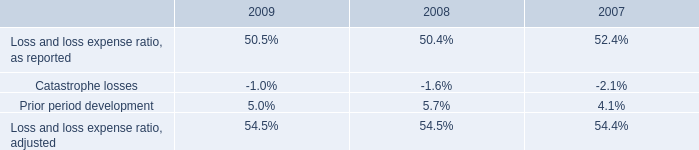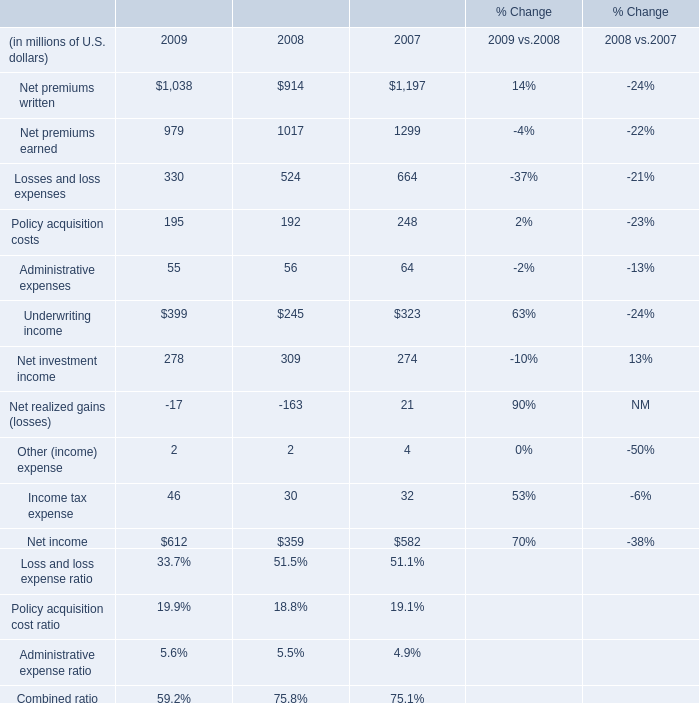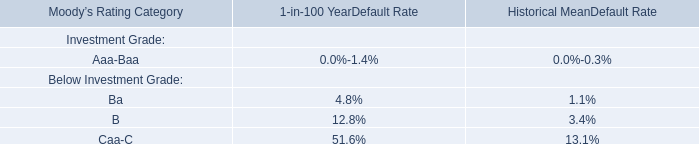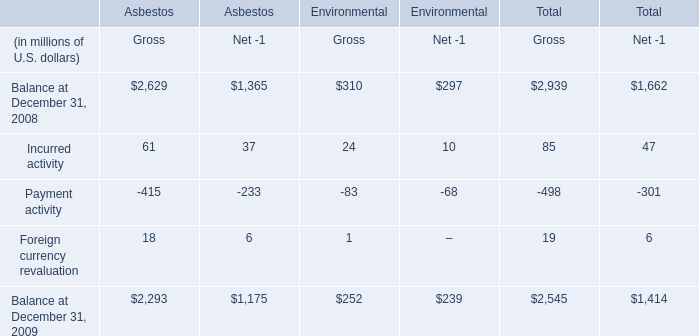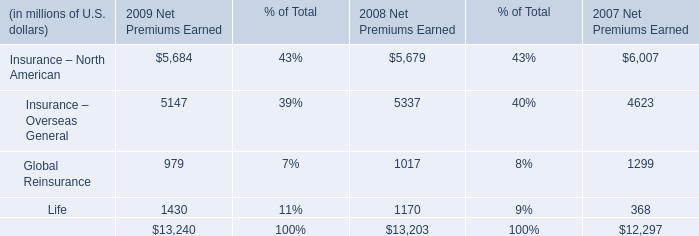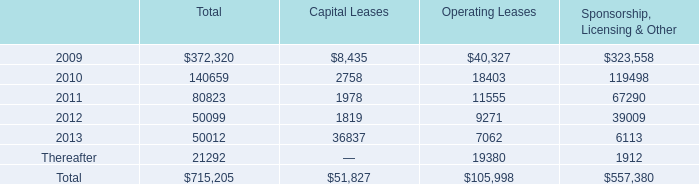In the year / section with lowest amount of Net premiums earned, what's the increasing rate of Net premiums written? 
Computations: ((1038 - 914) / 914)
Answer: 0.13567. 